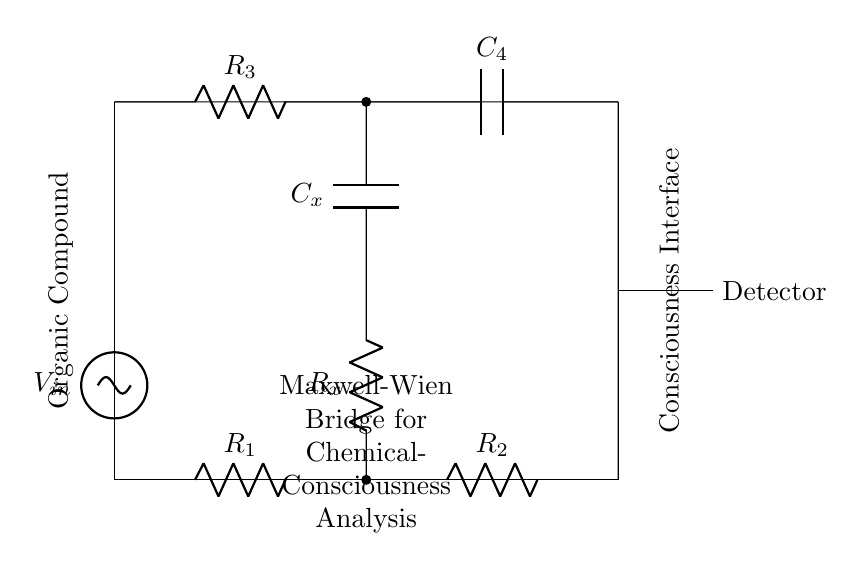What is the primary voltage source in this bridge circuit? The primary voltage source in the circuit is denoted as V_in, which provides the input voltage for the circuit operation.
Answer: V_in What type of component is connected to the organic compound? The organic compound is connected to a resistor R_x and a capacitor C_x, which are used for analyzing its electrical properties.
Answer: Resistor and Capacitor What is the function of the detector in this circuit? The detector is used for measuring the output signal from the bridge, which helps analyze the properties of the organic compound being tested.
Answer: Measurement Which two components are in series in the lower branch of the circuit? The lower branch consists of the resistor R_x and the capacitor C_x in series, which are crucial for analyzing the organic compound's impedance.
Answer: Resistor and Capacitor What overall method does this circuit illustrate? The circuit illustrates the Maxwell-Wien bridge method, specifically designed for impedance measurements pertaining to chemical analysis.
Answer: Bridge method What does the associated label "Consciousness Interface" imply about the application of this circuit? The label implies that the circuit may be used to connect the analysis of chemical properties with consciousness, possibly representing a metaphorical exploration of their relationship.
Answer: Connection of analysis with consciousness What ratio does the balance condition of a Maxwell-Wien bridge depend on? The balance condition depends on the ratio of the resistances and capacitances in the bridge, specifically R1:R2 = R3:Rx and Cx related to the bridge operation.
Answer: Resistance and capacitance ratio 